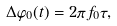Convert formula to latex. <formula><loc_0><loc_0><loc_500><loc_500>\Delta \varphi _ { 0 } ( t ) = 2 \pi f _ { 0 } \tau ,</formula> 